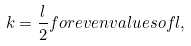Convert formula to latex. <formula><loc_0><loc_0><loc_500><loc_500>k = \frac { l } { 2 } f o r e v e n v a l u e s o f l ,</formula> 